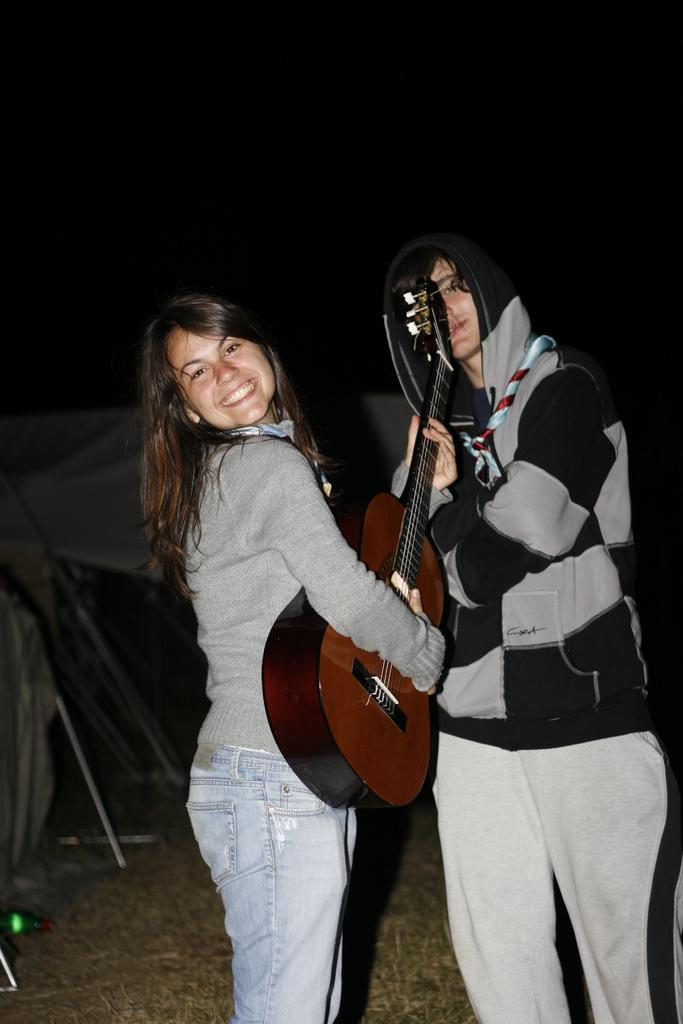What is the woman in the image doing? The woman is standing and smiling in the image. What is the woman holding in the image? The woman is holding a guitar in the image. Can you describe the man in the image? The man is standing and holding a guitar in the image. How many cats are sitting on the woman's shoe in the image? There are no cats or shoes present in the image. What type of jam is the man eating in the image? There is no jam or eating activity depicted in the image. 